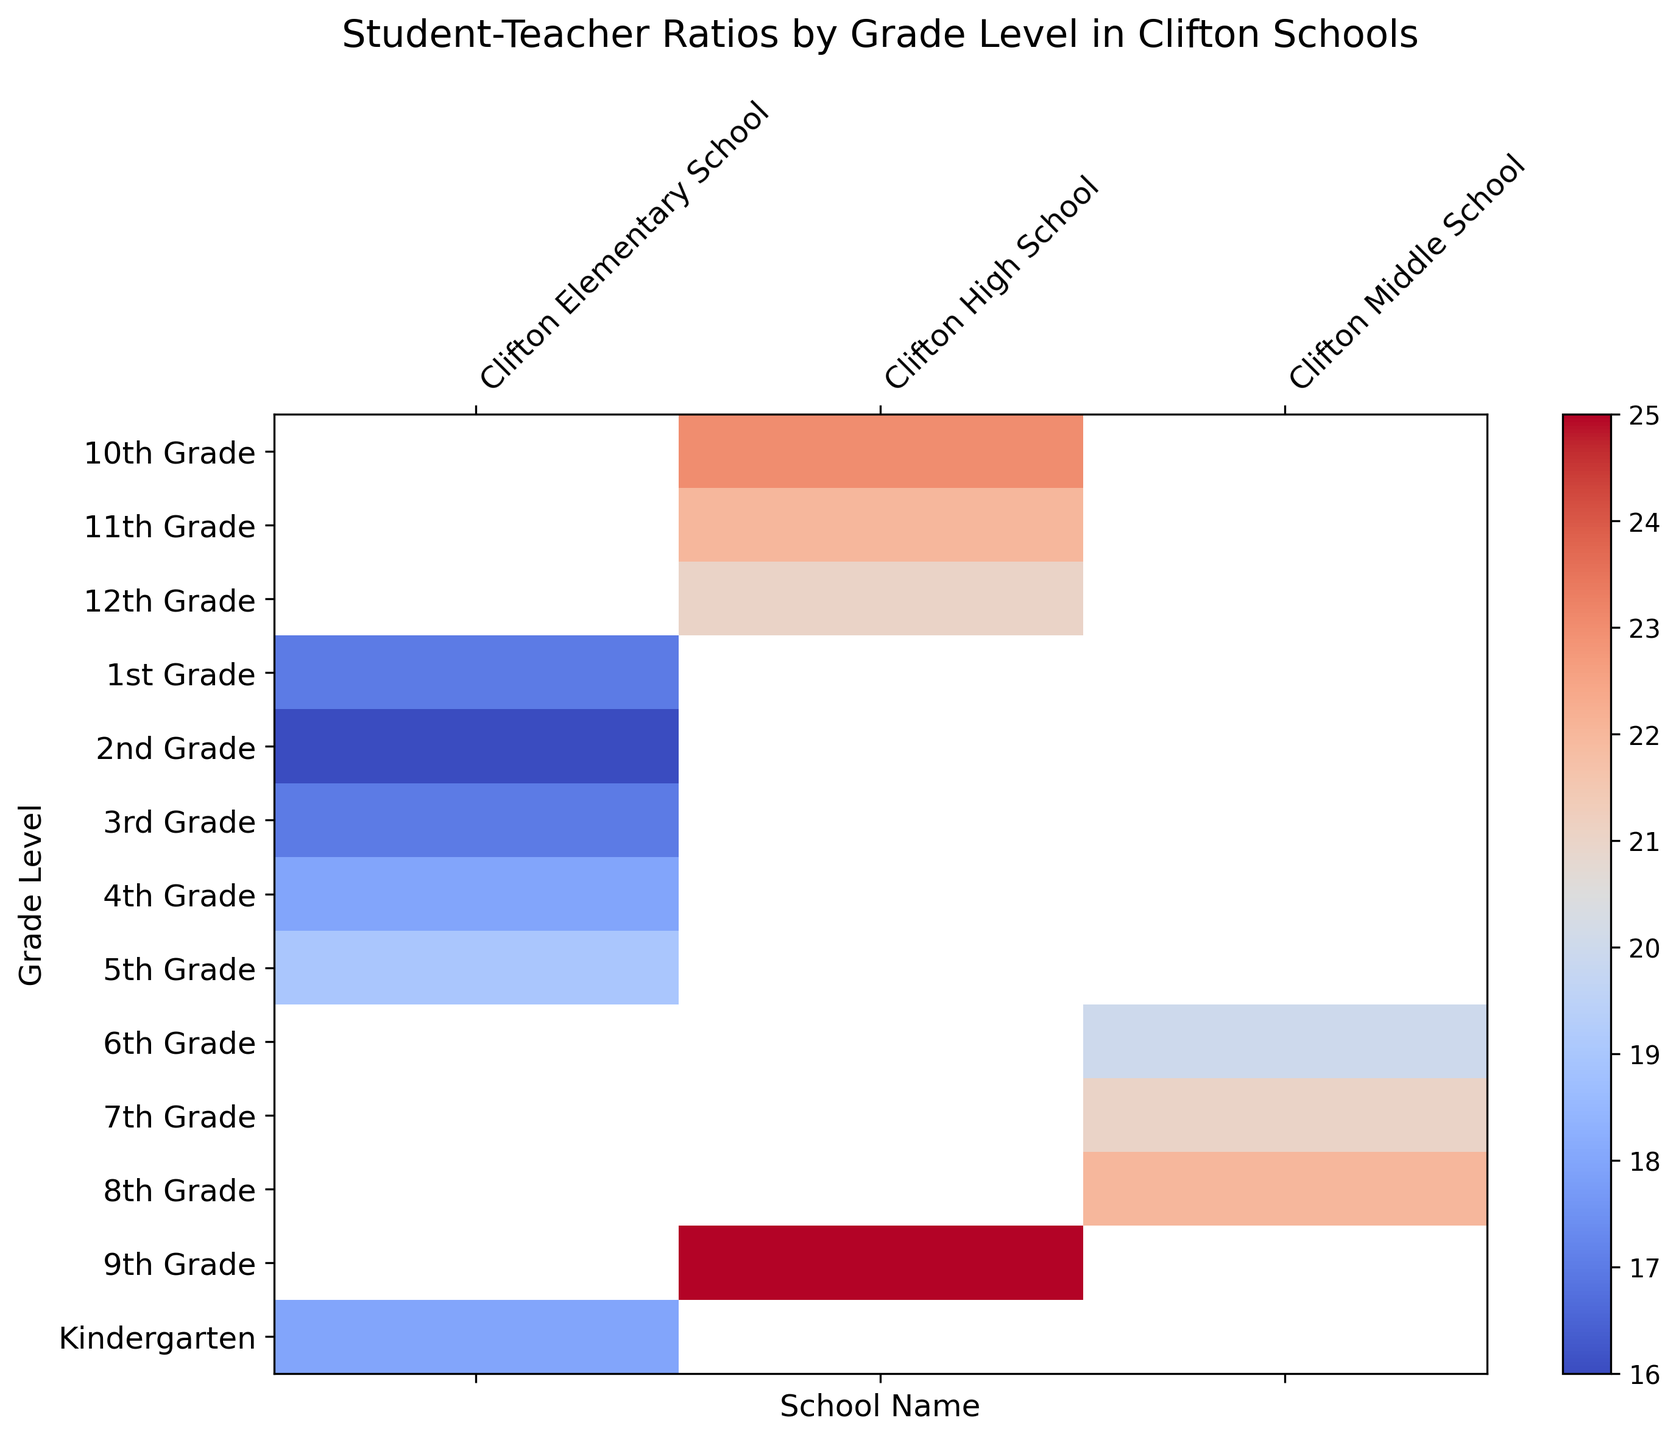Which school has the highest student-teacher ratio in the 9th grade? Look for the cell positions where the 9th grade and each school intersect to determine the ratios. Clifton High School has a ratio of 25, which is the highest.
Answer: Clifton High School What is the average student-teacher ratio across all grade levels in Clifton Elementary School? Sum the student-teacher ratios for each grade in Clifton Elementary School: (18 + 17 + 16 + 17 + 18 + 19). Then divide by the number of grades, which is 6. (18 + 17 + 16 + 17 + 18 + 19) / 6 = 17.5
Answer: 17.5 What's the difference in student-teacher ratios between 6th grade in Clifton Middle School and 12th grade in Clifton High School? Look at the values for 6th and 12th grades at their respective schools. 6th grade in Clifton Middle School is 20, and 12th grade in Clifton High School is 21. The difference is 21 - 20.
Answer: 1 How does the student-teacher ratio in Clifton Middle School change from 6th to 8th grade? Compare the ratios for 6th, 7th, and 8th grades in Clifton Middle School: 20, 21, and 22 respectively. The ratio increases by 1 each year.
Answer: Increases Which grade at Clifton Elementary School has the lowest student-teacher ratio? Look for the lowest number among the ratios for each grade at Clifton Elementary School. The 2nd grade has the lowest ratio of 16.
Answer: 2nd Grade What is the median student-teacher ratio for Clifton High School? List the student-teacher ratios for 9th-12th grades: 25, 23, 22, 21 and find the middle value. Since we have an even number of grades, the median is the average of 22 and 23: (22 + 23) / 2 = 22.5
Answer: 22.5 If we combine the student-teacher ratios for all the grades in Clifton Middle School, what would be the combined total? Add up the student-teacher ratios for 6th, 7th, and 8th grades in Clifton Middle School: 20 + 21 + 22 = 63.
Answer: 63 How does the student-teacher ratio in 4th grade compare to that in 5th grade at Clifton Elementary School? Compare the ratios of 4th grade (18) to 5th grade (19) at Clifton Elementary School. The ratio for 5th grade is higher by 1.
Answer: The ratio is higher by 1 in 5th grade For which grade level do Clifton High School and Clifton Middle School share the same student-teacher ratio? Compare the ratios for each grade between the two schools. None of the grade levels share the same student-teacher ratio.
Answer: None 